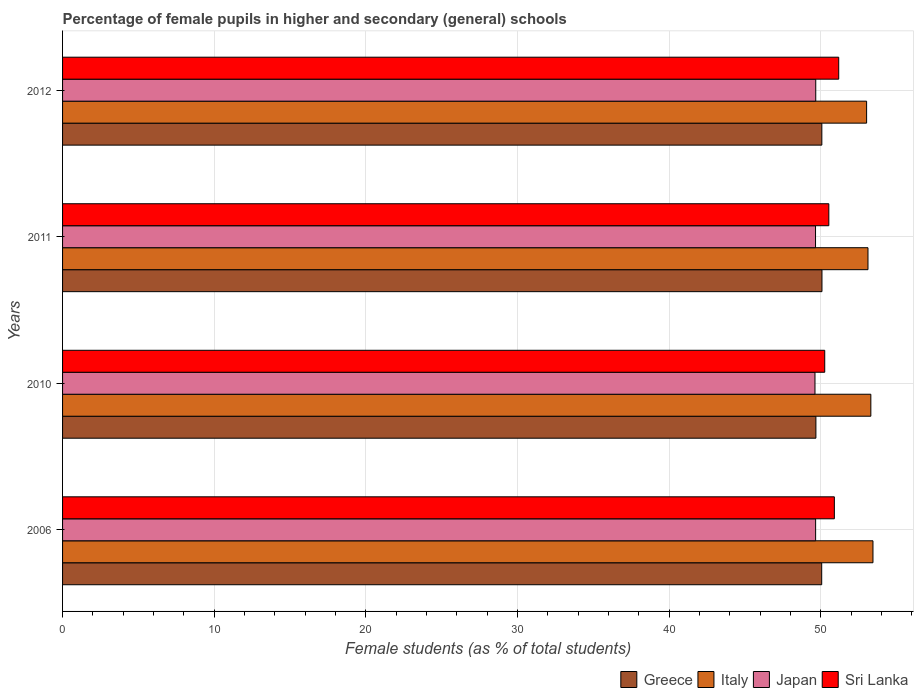How many different coloured bars are there?
Your answer should be very brief. 4. Are the number of bars per tick equal to the number of legend labels?
Give a very brief answer. Yes. Are the number of bars on each tick of the Y-axis equal?
Provide a short and direct response. Yes. How many bars are there on the 2nd tick from the bottom?
Your answer should be very brief. 4. What is the label of the 1st group of bars from the top?
Your response must be concise. 2012. In how many cases, is the number of bars for a given year not equal to the number of legend labels?
Your answer should be compact. 0. What is the percentage of female pupils in higher and secondary schools in Greece in 2011?
Offer a terse response. 50.08. Across all years, what is the maximum percentage of female pupils in higher and secondary schools in Italy?
Your answer should be compact. 53.44. Across all years, what is the minimum percentage of female pupils in higher and secondary schools in Sri Lanka?
Give a very brief answer. 50.26. In which year was the percentage of female pupils in higher and secondary schools in Italy minimum?
Ensure brevity in your answer.  2012. What is the total percentage of female pupils in higher and secondary schools in Sri Lanka in the graph?
Your answer should be compact. 202.86. What is the difference between the percentage of female pupils in higher and secondary schools in Japan in 2006 and that in 2011?
Your answer should be very brief. 0.01. What is the difference between the percentage of female pupils in higher and secondary schools in Sri Lanka in 2006 and the percentage of female pupils in higher and secondary schools in Italy in 2012?
Offer a very short reply. -2.13. What is the average percentage of female pupils in higher and secondary schools in Japan per year?
Keep it short and to the point. 49.65. In the year 2006, what is the difference between the percentage of female pupils in higher and secondary schools in Japan and percentage of female pupils in higher and secondary schools in Greece?
Offer a terse response. -0.4. In how many years, is the percentage of female pupils in higher and secondary schools in Sri Lanka greater than 28 %?
Your response must be concise. 4. What is the ratio of the percentage of female pupils in higher and secondary schools in Sri Lanka in 2011 to that in 2012?
Offer a very short reply. 0.99. Is the percentage of female pupils in higher and secondary schools in Sri Lanka in 2010 less than that in 2012?
Give a very brief answer. Yes. What is the difference between the highest and the second highest percentage of female pupils in higher and secondary schools in Greece?
Your response must be concise. 0.01. What is the difference between the highest and the lowest percentage of female pupils in higher and secondary schools in Italy?
Your response must be concise. 0.42. Is the sum of the percentage of female pupils in higher and secondary schools in Italy in 2006 and 2011 greater than the maximum percentage of female pupils in higher and secondary schools in Japan across all years?
Your answer should be very brief. Yes. Is it the case that in every year, the sum of the percentage of female pupils in higher and secondary schools in Italy and percentage of female pupils in higher and secondary schools in Japan is greater than the percentage of female pupils in higher and secondary schools in Greece?
Give a very brief answer. Yes. Are all the bars in the graph horizontal?
Provide a short and direct response. Yes. What is the difference between two consecutive major ticks on the X-axis?
Your answer should be compact. 10. Does the graph contain any zero values?
Keep it short and to the point. No. Where does the legend appear in the graph?
Provide a short and direct response. Bottom right. How many legend labels are there?
Offer a terse response. 4. How are the legend labels stacked?
Ensure brevity in your answer.  Horizontal. What is the title of the graph?
Offer a very short reply. Percentage of female pupils in higher and secondary (general) schools. Does "Djibouti" appear as one of the legend labels in the graph?
Keep it short and to the point. No. What is the label or title of the X-axis?
Ensure brevity in your answer.  Female students (as % of total students). What is the label or title of the Y-axis?
Give a very brief answer. Years. What is the Female students (as % of total students) of Greece in 2006?
Offer a terse response. 50.06. What is the Female students (as % of total students) in Italy in 2006?
Provide a short and direct response. 53.44. What is the Female students (as % of total students) in Japan in 2006?
Keep it short and to the point. 49.66. What is the Female students (as % of total students) in Sri Lanka in 2006?
Give a very brief answer. 50.89. What is the Female students (as % of total students) of Greece in 2010?
Your response must be concise. 49.68. What is the Female students (as % of total students) in Italy in 2010?
Provide a short and direct response. 53.3. What is the Female students (as % of total students) of Japan in 2010?
Make the answer very short. 49.62. What is the Female students (as % of total students) in Sri Lanka in 2010?
Offer a very short reply. 50.26. What is the Female students (as % of total students) of Greece in 2011?
Offer a terse response. 50.08. What is the Female students (as % of total students) of Italy in 2011?
Keep it short and to the point. 53.11. What is the Female students (as % of total students) in Japan in 2011?
Ensure brevity in your answer.  49.65. What is the Female students (as % of total students) of Sri Lanka in 2011?
Offer a terse response. 50.53. What is the Female students (as % of total students) in Greece in 2012?
Offer a very short reply. 50.07. What is the Female students (as % of total students) of Italy in 2012?
Make the answer very short. 53.02. What is the Female students (as % of total students) in Japan in 2012?
Provide a succinct answer. 49.67. What is the Female students (as % of total students) in Sri Lanka in 2012?
Make the answer very short. 51.18. Across all years, what is the maximum Female students (as % of total students) in Greece?
Keep it short and to the point. 50.08. Across all years, what is the maximum Female students (as % of total students) of Italy?
Ensure brevity in your answer.  53.44. Across all years, what is the maximum Female students (as % of total students) of Japan?
Offer a terse response. 49.67. Across all years, what is the maximum Female students (as % of total students) in Sri Lanka?
Give a very brief answer. 51.18. Across all years, what is the minimum Female students (as % of total students) of Greece?
Your response must be concise. 49.68. Across all years, what is the minimum Female students (as % of total students) in Italy?
Your answer should be compact. 53.02. Across all years, what is the minimum Female students (as % of total students) of Japan?
Offer a terse response. 49.62. Across all years, what is the minimum Female students (as % of total students) in Sri Lanka?
Make the answer very short. 50.26. What is the total Female students (as % of total students) in Greece in the graph?
Give a very brief answer. 199.88. What is the total Female students (as % of total students) in Italy in the graph?
Provide a short and direct response. 212.87. What is the total Female students (as % of total students) in Japan in the graph?
Make the answer very short. 198.59. What is the total Female students (as % of total students) in Sri Lanka in the graph?
Offer a terse response. 202.86. What is the difference between the Female students (as % of total students) of Greece in 2006 and that in 2010?
Make the answer very short. 0.38. What is the difference between the Female students (as % of total students) in Italy in 2006 and that in 2010?
Ensure brevity in your answer.  0.14. What is the difference between the Female students (as % of total students) in Japan in 2006 and that in 2010?
Ensure brevity in your answer.  0.04. What is the difference between the Female students (as % of total students) in Sri Lanka in 2006 and that in 2010?
Your answer should be compact. 0.64. What is the difference between the Female students (as % of total students) in Greece in 2006 and that in 2011?
Your answer should be very brief. -0.02. What is the difference between the Female students (as % of total students) in Italy in 2006 and that in 2011?
Offer a very short reply. 0.33. What is the difference between the Female students (as % of total students) in Japan in 2006 and that in 2011?
Give a very brief answer. 0.01. What is the difference between the Female students (as % of total students) of Sri Lanka in 2006 and that in 2011?
Make the answer very short. 0.37. What is the difference between the Female students (as % of total students) of Greece in 2006 and that in 2012?
Provide a short and direct response. -0.01. What is the difference between the Female students (as % of total students) in Italy in 2006 and that in 2012?
Your answer should be compact. 0.42. What is the difference between the Female students (as % of total students) of Japan in 2006 and that in 2012?
Offer a terse response. -0.01. What is the difference between the Female students (as % of total students) in Sri Lanka in 2006 and that in 2012?
Make the answer very short. -0.29. What is the difference between the Female students (as % of total students) of Greece in 2010 and that in 2011?
Offer a very short reply. -0.4. What is the difference between the Female students (as % of total students) of Italy in 2010 and that in 2011?
Offer a terse response. 0.19. What is the difference between the Female students (as % of total students) in Japan in 2010 and that in 2011?
Provide a succinct answer. -0.04. What is the difference between the Female students (as % of total students) in Sri Lanka in 2010 and that in 2011?
Make the answer very short. -0.27. What is the difference between the Female students (as % of total students) of Greece in 2010 and that in 2012?
Offer a terse response. -0.39. What is the difference between the Female students (as % of total students) of Italy in 2010 and that in 2012?
Provide a short and direct response. 0.28. What is the difference between the Female students (as % of total students) of Japan in 2010 and that in 2012?
Keep it short and to the point. -0.05. What is the difference between the Female students (as % of total students) of Sri Lanka in 2010 and that in 2012?
Give a very brief answer. -0.92. What is the difference between the Female students (as % of total students) in Greece in 2011 and that in 2012?
Give a very brief answer. 0.01. What is the difference between the Female students (as % of total students) of Italy in 2011 and that in 2012?
Make the answer very short. 0.09. What is the difference between the Female students (as % of total students) in Japan in 2011 and that in 2012?
Offer a very short reply. -0.02. What is the difference between the Female students (as % of total students) in Sri Lanka in 2011 and that in 2012?
Offer a very short reply. -0.65. What is the difference between the Female students (as % of total students) in Greece in 2006 and the Female students (as % of total students) in Italy in 2010?
Offer a very short reply. -3.24. What is the difference between the Female students (as % of total students) of Greece in 2006 and the Female students (as % of total students) of Japan in 2010?
Make the answer very short. 0.44. What is the difference between the Female students (as % of total students) of Greece in 2006 and the Female students (as % of total students) of Sri Lanka in 2010?
Give a very brief answer. -0.2. What is the difference between the Female students (as % of total students) of Italy in 2006 and the Female students (as % of total students) of Japan in 2010?
Offer a very short reply. 3.82. What is the difference between the Female students (as % of total students) in Italy in 2006 and the Female students (as % of total students) in Sri Lanka in 2010?
Provide a succinct answer. 3.18. What is the difference between the Female students (as % of total students) of Japan in 2006 and the Female students (as % of total students) of Sri Lanka in 2010?
Make the answer very short. -0.6. What is the difference between the Female students (as % of total students) in Greece in 2006 and the Female students (as % of total students) in Italy in 2011?
Your answer should be compact. -3.05. What is the difference between the Female students (as % of total students) in Greece in 2006 and the Female students (as % of total students) in Japan in 2011?
Offer a terse response. 0.41. What is the difference between the Female students (as % of total students) in Greece in 2006 and the Female students (as % of total students) in Sri Lanka in 2011?
Ensure brevity in your answer.  -0.47. What is the difference between the Female students (as % of total students) in Italy in 2006 and the Female students (as % of total students) in Japan in 2011?
Provide a short and direct response. 3.79. What is the difference between the Female students (as % of total students) in Italy in 2006 and the Female students (as % of total students) in Sri Lanka in 2011?
Provide a succinct answer. 2.91. What is the difference between the Female students (as % of total students) of Japan in 2006 and the Female students (as % of total students) of Sri Lanka in 2011?
Give a very brief answer. -0.87. What is the difference between the Female students (as % of total students) of Greece in 2006 and the Female students (as % of total students) of Italy in 2012?
Offer a very short reply. -2.96. What is the difference between the Female students (as % of total students) in Greece in 2006 and the Female students (as % of total students) in Japan in 2012?
Your response must be concise. 0.39. What is the difference between the Female students (as % of total students) in Greece in 2006 and the Female students (as % of total students) in Sri Lanka in 2012?
Provide a short and direct response. -1.12. What is the difference between the Female students (as % of total students) of Italy in 2006 and the Female students (as % of total students) of Japan in 2012?
Offer a terse response. 3.77. What is the difference between the Female students (as % of total students) of Italy in 2006 and the Female students (as % of total students) of Sri Lanka in 2012?
Make the answer very short. 2.26. What is the difference between the Female students (as % of total students) of Japan in 2006 and the Female students (as % of total students) of Sri Lanka in 2012?
Your response must be concise. -1.52. What is the difference between the Female students (as % of total students) of Greece in 2010 and the Female students (as % of total students) of Italy in 2011?
Your answer should be compact. -3.43. What is the difference between the Female students (as % of total students) of Greece in 2010 and the Female students (as % of total students) of Japan in 2011?
Offer a very short reply. 0.02. What is the difference between the Female students (as % of total students) of Greece in 2010 and the Female students (as % of total students) of Sri Lanka in 2011?
Make the answer very short. -0.85. What is the difference between the Female students (as % of total students) in Italy in 2010 and the Female students (as % of total students) in Japan in 2011?
Keep it short and to the point. 3.65. What is the difference between the Female students (as % of total students) of Italy in 2010 and the Female students (as % of total students) of Sri Lanka in 2011?
Keep it short and to the point. 2.77. What is the difference between the Female students (as % of total students) in Japan in 2010 and the Female students (as % of total students) in Sri Lanka in 2011?
Keep it short and to the point. -0.91. What is the difference between the Female students (as % of total students) in Greece in 2010 and the Female students (as % of total students) in Italy in 2012?
Give a very brief answer. -3.34. What is the difference between the Female students (as % of total students) in Greece in 2010 and the Female students (as % of total students) in Japan in 2012?
Offer a terse response. 0.01. What is the difference between the Female students (as % of total students) in Greece in 2010 and the Female students (as % of total students) in Sri Lanka in 2012?
Make the answer very short. -1.5. What is the difference between the Female students (as % of total students) in Italy in 2010 and the Female students (as % of total students) in Japan in 2012?
Make the answer very short. 3.63. What is the difference between the Female students (as % of total students) of Italy in 2010 and the Female students (as % of total students) of Sri Lanka in 2012?
Give a very brief answer. 2.12. What is the difference between the Female students (as % of total students) in Japan in 2010 and the Female students (as % of total students) in Sri Lanka in 2012?
Offer a terse response. -1.56. What is the difference between the Female students (as % of total students) in Greece in 2011 and the Female students (as % of total students) in Italy in 2012?
Give a very brief answer. -2.94. What is the difference between the Female students (as % of total students) in Greece in 2011 and the Female students (as % of total students) in Japan in 2012?
Keep it short and to the point. 0.41. What is the difference between the Female students (as % of total students) in Greece in 2011 and the Female students (as % of total students) in Sri Lanka in 2012?
Your answer should be compact. -1.1. What is the difference between the Female students (as % of total students) in Italy in 2011 and the Female students (as % of total students) in Japan in 2012?
Keep it short and to the point. 3.44. What is the difference between the Female students (as % of total students) of Italy in 2011 and the Female students (as % of total students) of Sri Lanka in 2012?
Provide a short and direct response. 1.93. What is the difference between the Female students (as % of total students) in Japan in 2011 and the Female students (as % of total students) in Sri Lanka in 2012?
Give a very brief answer. -1.53. What is the average Female students (as % of total students) of Greece per year?
Offer a very short reply. 49.97. What is the average Female students (as % of total students) in Italy per year?
Your response must be concise. 53.22. What is the average Female students (as % of total students) in Japan per year?
Give a very brief answer. 49.65. What is the average Female students (as % of total students) of Sri Lanka per year?
Make the answer very short. 50.71. In the year 2006, what is the difference between the Female students (as % of total students) of Greece and Female students (as % of total students) of Italy?
Keep it short and to the point. -3.38. In the year 2006, what is the difference between the Female students (as % of total students) of Greece and Female students (as % of total students) of Japan?
Your answer should be compact. 0.4. In the year 2006, what is the difference between the Female students (as % of total students) of Greece and Female students (as % of total students) of Sri Lanka?
Offer a terse response. -0.83. In the year 2006, what is the difference between the Female students (as % of total students) of Italy and Female students (as % of total students) of Japan?
Ensure brevity in your answer.  3.78. In the year 2006, what is the difference between the Female students (as % of total students) of Italy and Female students (as % of total students) of Sri Lanka?
Give a very brief answer. 2.55. In the year 2006, what is the difference between the Female students (as % of total students) in Japan and Female students (as % of total students) in Sri Lanka?
Give a very brief answer. -1.24. In the year 2010, what is the difference between the Female students (as % of total students) of Greece and Female students (as % of total students) of Italy?
Give a very brief answer. -3.62. In the year 2010, what is the difference between the Female students (as % of total students) of Greece and Female students (as % of total students) of Japan?
Offer a very short reply. 0.06. In the year 2010, what is the difference between the Female students (as % of total students) of Greece and Female students (as % of total students) of Sri Lanka?
Offer a terse response. -0.58. In the year 2010, what is the difference between the Female students (as % of total students) of Italy and Female students (as % of total students) of Japan?
Ensure brevity in your answer.  3.68. In the year 2010, what is the difference between the Female students (as % of total students) of Italy and Female students (as % of total students) of Sri Lanka?
Offer a very short reply. 3.04. In the year 2010, what is the difference between the Female students (as % of total students) in Japan and Female students (as % of total students) in Sri Lanka?
Your answer should be very brief. -0.64. In the year 2011, what is the difference between the Female students (as % of total students) in Greece and Female students (as % of total students) in Italy?
Provide a succinct answer. -3.03. In the year 2011, what is the difference between the Female students (as % of total students) in Greece and Female students (as % of total students) in Japan?
Your response must be concise. 0.42. In the year 2011, what is the difference between the Female students (as % of total students) in Greece and Female students (as % of total students) in Sri Lanka?
Provide a short and direct response. -0.45. In the year 2011, what is the difference between the Female students (as % of total students) of Italy and Female students (as % of total students) of Japan?
Give a very brief answer. 3.46. In the year 2011, what is the difference between the Female students (as % of total students) of Italy and Female students (as % of total students) of Sri Lanka?
Your answer should be very brief. 2.58. In the year 2011, what is the difference between the Female students (as % of total students) of Japan and Female students (as % of total students) of Sri Lanka?
Provide a succinct answer. -0.88. In the year 2012, what is the difference between the Female students (as % of total students) of Greece and Female students (as % of total students) of Italy?
Keep it short and to the point. -2.95. In the year 2012, what is the difference between the Female students (as % of total students) of Greece and Female students (as % of total students) of Japan?
Your answer should be very brief. 0.4. In the year 2012, what is the difference between the Female students (as % of total students) in Greece and Female students (as % of total students) in Sri Lanka?
Provide a short and direct response. -1.11. In the year 2012, what is the difference between the Female students (as % of total students) in Italy and Female students (as % of total students) in Japan?
Your answer should be compact. 3.35. In the year 2012, what is the difference between the Female students (as % of total students) in Italy and Female students (as % of total students) in Sri Lanka?
Your answer should be compact. 1.84. In the year 2012, what is the difference between the Female students (as % of total students) of Japan and Female students (as % of total students) of Sri Lanka?
Offer a terse response. -1.51. What is the ratio of the Female students (as % of total students) in Greece in 2006 to that in 2010?
Make the answer very short. 1.01. What is the ratio of the Female students (as % of total students) in Japan in 2006 to that in 2010?
Offer a terse response. 1. What is the ratio of the Female students (as % of total students) in Sri Lanka in 2006 to that in 2010?
Your answer should be compact. 1.01. What is the ratio of the Female students (as % of total students) in Greece in 2006 to that in 2011?
Ensure brevity in your answer.  1. What is the ratio of the Female students (as % of total students) in Italy in 2006 to that in 2011?
Ensure brevity in your answer.  1.01. What is the ratio of the Female students (as % of total students) of Greece in 2006 to that in 2012?
Give a very brief answer. 1. What is the ratio of the Female students (as % of total students) of Italy in 2006 to that in 2012?
Give a very brief answer. 1.01. What is the ratio of the Female students (as % of total students) of Japan in 2006 to that in 2012?
Offer a very short reply. 1. What is the ratio of the Female students (as % of total students) of Greece in 2010 to that in 2011?
Provide a short and direct response. 0.99. What is the ratio of the Female students (as % of total students) of Greece in 2010 to that in 2012?
Provide a succinct answer. 0.99. What is the ratio of the Female students (as % of total students) in Italy in 2010 to that in 2012?
Offer a terse response. 1.01. What is the ratio of the Female students (as % of total students) in Japan in 2010 to that in 2012?
Provide a succinct answer. 1. What is the ratio of the Female students (as % of total students) in Japan in 2011 to that in 2012?
Offer a terse response. 1. What is the ratio of the Female students (as % of total students) of Sri Lanka in 2011 to that in 2012?
Make the answer very short. 0.99. What is the difference between the highest and the second highest Female students (as % of total students) of Greece?
Ensure brevity in your answer.  0.01. What is the difference between the highest and the second highest Female students (as % of total students) in Italy?
Offer a terse response. 0.14. What is the difference between the highest and the second highest Female students (as % of total students) in Japan?
Offer a very short reply. 0.01. What is the difference between the highest and the second highest Female students (as % of total students) in Sri Lanka?
Your answer should be compact. 0.29. What is the difference between the highest and the lowest Female students (as % of total students) of Greece?
Your response must be concise. 0.4. What is the difference between the highest and the lowest Female students (as % of total students) in Italy?
Offer a terse response. 0.42. What is the difference between the highest and the lowest Female students (as % of total students) of Japan?
Provide a short and direct response. 0.05. What is the difference between the highest and the lowest Female students (as % of total students) in Sri Lanka?
Your response must be concise. 0.92. 